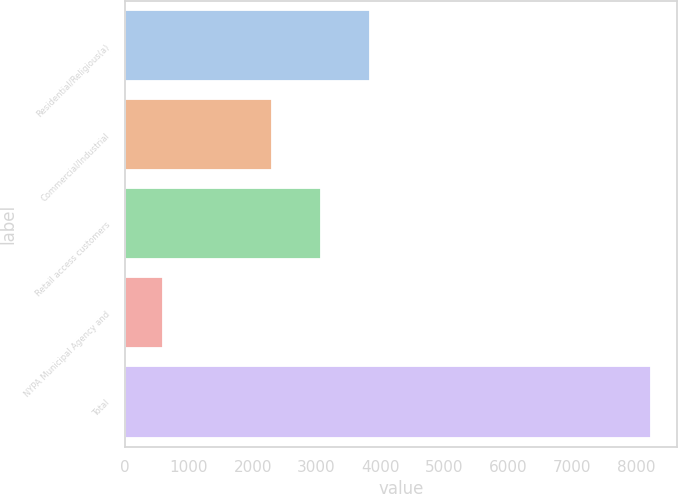Convert chart. <chart><loc_0><loc_0><loc_500><loc_500><bar_chart><fcel>Residential/Religious(a)<fcel>Commercial/Industrial<fcel>Retail access customers<fcel>NYPA Municipal Agency and<fcel>Total<nl><fcel>3831.2<fcel>2304<fcel>3067.6<fcel>592<fcel>8228<nl></chart> 